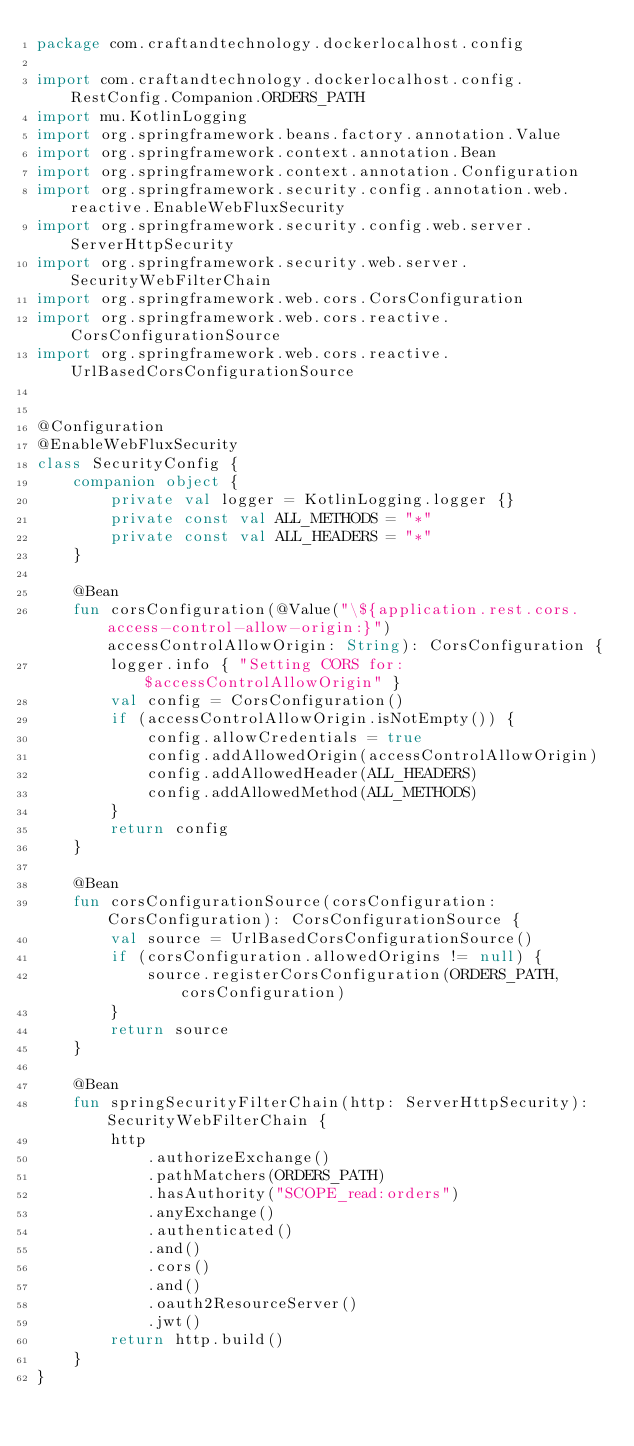<code> <loc_0><loc_0><loc_500><loc_500><_Kotlin_>package com.craftandtechnology.dockerlocalhost.config

import com.craftandtechnology.dockerlocalhost.config.RestConfig.Companion.ORDERS_PATH
import mu.KotlinLogging
import org.springframework.beans.factory.annotation.Value
import org.springframework.context.annotation.Bean
import org.springframework.context.annotation.Configuration
import org.springframework.security.config.annotation.web.reactive.EnableWebFluxSecurity
import org.springframework.security.config.web.server.ServerHttpSecurity
import org.springframework.security.web.server.SecurityWebFilterChain
import org.springframework.web.cors.CorsConfiguration
import org.springframework.web.cors.reactive.CorsConfigurationSource
import org.springframework.web.cors.reactive.UrlBasedCorsConfigurationSource


@Configuration
@EnableWebFluxSecurity
class SecurityConfig {
    companion object {
        private val logger = KotlinLogging.logger {}
        private const val ALL_METHODS = "*"
        private const val ALL_HEADERS = "*"
    }

    @Bean
    fun corsConfiguration(@Value("\${application.rest.cors.access-control-allow-origin:}") accessControlAllowOrigin: String): CorsConfiguration {
        logger.info { "Setting CORS for: $accessControlAllowOrigin" }
        val config = CorsConfiguration()
        if (accessControlAllowOrigin.isNotEmpty()) {
            config.allowCredentials = true
            config.addAllowedOrigin(accessControlAllowOrigin)
            config.addAllowedHeader(ALL_HEADERS)
            config.addAllowedMethod(ALL_METHODS)
        }
        return config
    }

    @Bean
    fun corsConfigurationSource(corsConfiguration: CorsConfiguration): CorsConfigurationSource {
        val source = UrlBasedCorsConfigurationSource()
        if (corsConfiguration.allowedOrigins != null) {
            source.registerCorsConfiguration(ORDERS_PATH, corsConfiguration)
        }
        return source
    }

    @Bean
    fun springSecurityFilterChain(http: ServerHttpSecurity): SecurityWebFilterChain {
        http
            .authorizeExchange()
            .pathMatchers(ORDERS_PATH)
            .hasAuthority("SCOPE_read:orders")
            .anyExchange()
            .authenticated()
            .and()
            .cors()
            .and()
            .oauth2ResourceServer()
            .jwt()
        return http.build()
    }
}</code> 